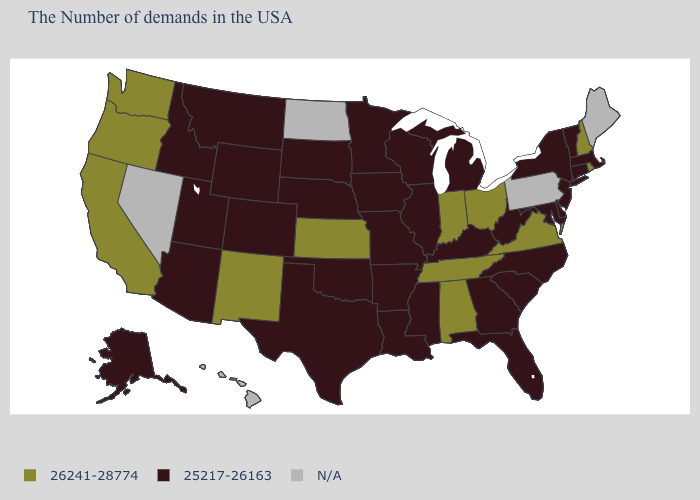Among the states that border Nevada , does Idaho have the lowest value?
Concise answer only. Yes. Name the states that have a value in the range 26241-28774?
Keep it brief. Rhode Island, New Hampshire, Virginia, Ohio, Indiana, Alabama, Tennessee, Kansas, New Mexico, California, Washington, Oregon. What is the value of Massachusetts?
Quick response, please. 25217-26163. How many symbols are there in the legend?
Quick response, please. 3. What is the value of Virginia?
Write a very short answer. 26241-28774. Among the states that border Massachusetts , does Connecticut have the lowest value?
Answer briefly. Yes. Does New Jersey have the highest value in the USA?
Give a very brief answer. No. Does the first symbol in the legend represent the smallest category?
Answer briefly. No. Name the states that have a value in the range 25217-26163?
Short answer required. Massachusetts, Vermont, Connecticut, New York, New Jersey, Delaware, Maryland, North Carolina, South Carolina, West Virginia, Florida, Georgia, Michigan, Kentucky, Wisconsin, Illinois, Mississippi, Louisiana, Missouri, Arkansas, Minnesota, Iowa, Nebraska, Oklahoma, Texas, South Dakota, Wyoming, Colorado, Utah, Montana, Arizona, Idaho, Alaska. What is the lowest value in the MidWest?
Keep it brief. 25217-26163. Among the states that border Illinois , which have the highest value?
Answer briefly. Indiana. What is the value of New Jersey?
Answer briefly. 25217-26163. Name the states that have a value in the range 26241-28774?
Answer briefly. Rhode Island, New Hampshire, Virginia, Ohio, Indiana, Alabama, Tennessee, Kansas, New Mexico, California, Washington, Oregon. Does the map have missing data?
Concise answer only. Yes. Does Wyoming have the highest value in the West?
Write a very short answer. No. 